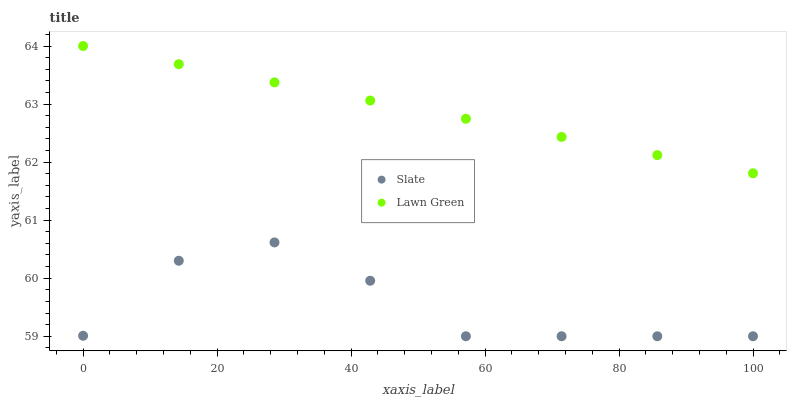Does Slate have the minimum area under the curve?
Answer yes or no. Yes. Does Lawn Green have the maximum area under the curve?
Answer yes or no. Yes. Does Slate have the maximum area under the curve?
Answer yes or no. No. Is Lawn Green the smoothest?
Answer yes or no. Yes. Is Slate the roughest?
Answer yes or no. Yes. Is Slate the smoothest?
Answer yes or no. No. Does Slate have the lowest value?
Answer yes or no. Yes. Does Lawn Green have the highest value?
Answer yes or no. Yes. Does Slate have the highest value?
Answer yes or no. No. Is Slate less than Lawn Green?
Answer yes or no. Yes. Is Lawn Green greater than Slate?
Answer yes or no. Yes. Does Slate intersect Lawn Green?
Answer yes or no. No. 